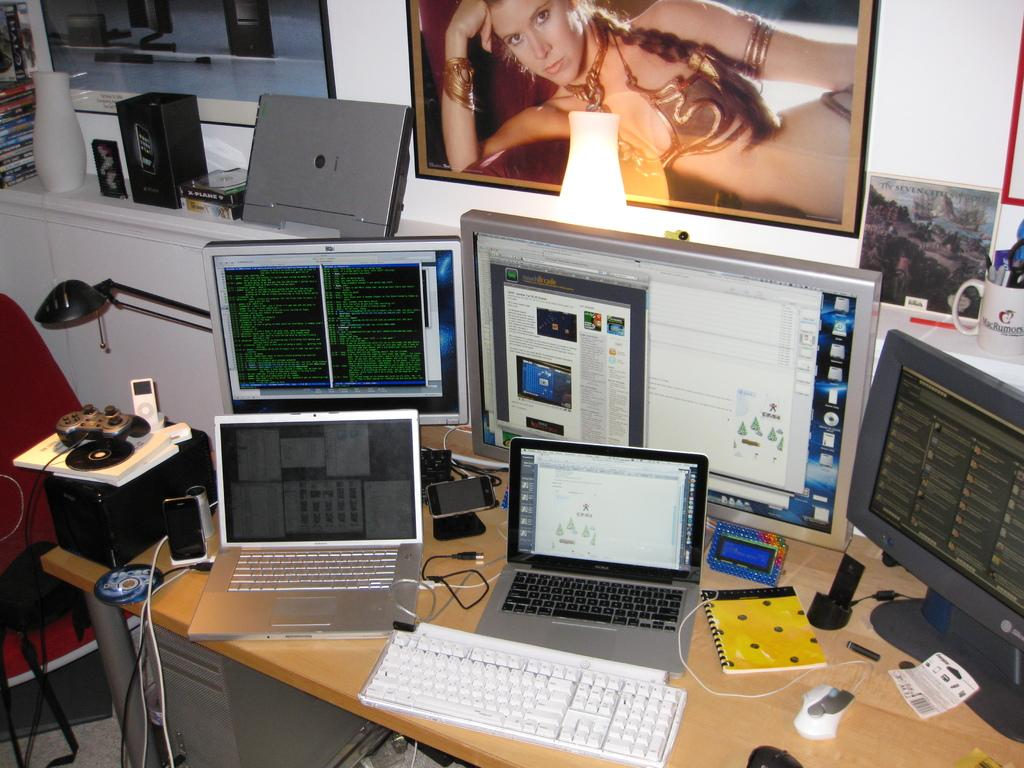What electronic devices are present on the table in the image? There are laptops, a monitor, a mouse, and a keyboard on the table. What other items can be seen on the table? There is a mobile phone and a notebook on the table. What objects are visible in the background of the image? There is a photo frame, a cup, a flower vase, and books in the background. What type of zinc can be seen in the image? There is no zinc present in the image. How many feet are visible in the image? There are no feet visible in the image. 